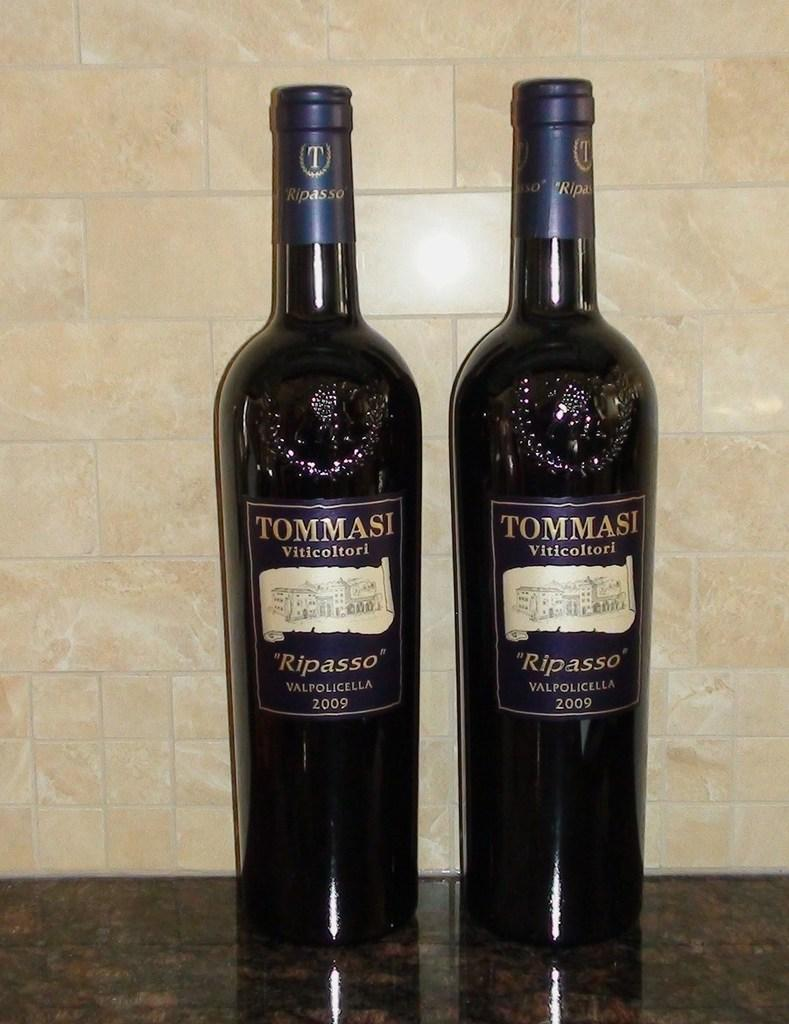<image>
Offer a succinct explanation of the picture presented. Two Tommasi wine bottle next to one another in front of a wall. 